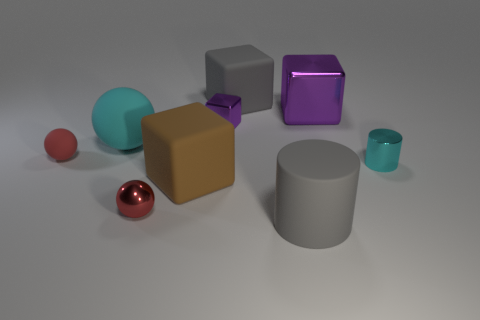Subtract 1 cubes. How many cubes are left? 3 Subtract all gray rubber cubes. How many cubes are left? 3 Subtract all cyan cubes. Subtract all cyan spheres. How many cubes are left? 4 Subtract all cylinders. How many objects are left? 7 Add 5 large blue metal things. How many large blue metal things exist? 5 Subtract 0 yellow cylinders. How many objects are left? 9 Subtract all tiny rubber spheres. Subtract all big cylinders. How many objects are left? 7 Add 9 red metal things. How many red metal things are left? 10 